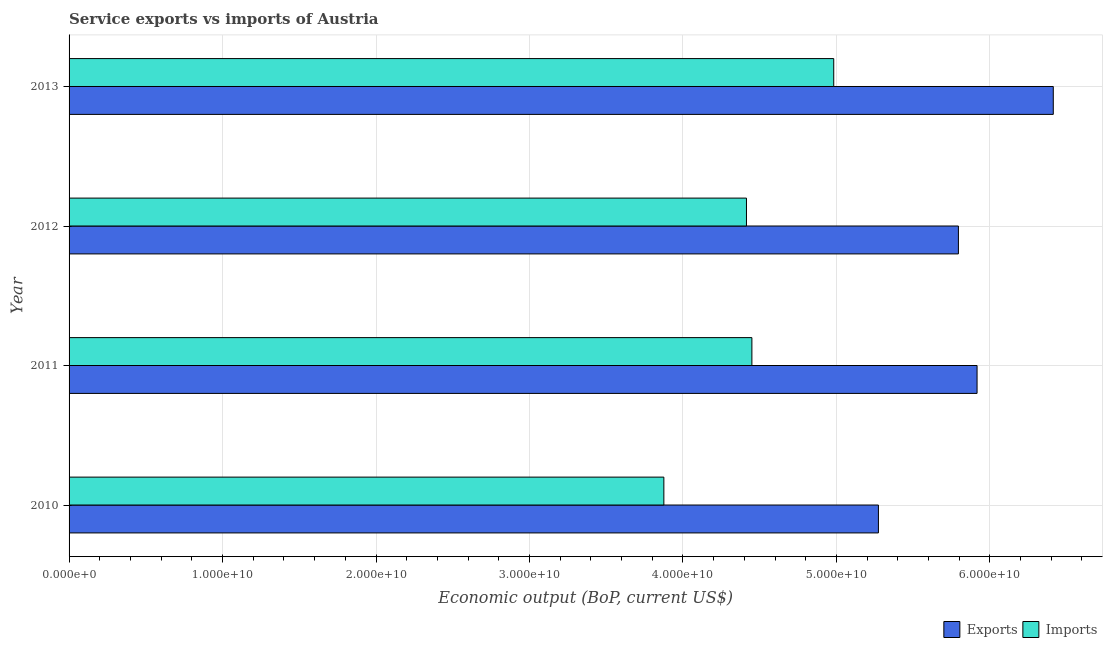How many groups of bars are there?
Ensure brevity in your answer.  4. What is the label of the 3rd group of bars from the top?
Your response must be concise. 2011. In how many cases, is the number of bars for a given year not equal to the number of legend labels?
Offer a very short reply. 0. What is the amount of service exports in 2010?
Give a very brief answer. 5.27e+1. Across all years, what is the maximum amount of service imports?
Make the answer very short. 4.98e+1. Across all years, what is the minimum amount of service imports?
Your answer should be compact. 3.88e+1. In which year was the amount of service exports maximum?
Give a very brief answer. 2013. What is the total amount of service exports in the graph?
Give a very brief answer. 2.34e+11. What is the difference between the amount of service imports in 2010 and that in 2013?
Your answer should be very brief. -1.11e+1. What is the difference between the amount of service imports in 2012 and the amount of service exports in 2013?
Offer a terse response. -2.00e+1. What is the average amount of service imports per year?
Keep it short and to the point. 4.43e+1. In the year 2010, what is the difference between the amount of service exports and amount of service imports?
Your response must be concise. 1.40e+1. What is the ratio of the amount of service exports in 2012 to that in 2013?
Your answer should be very brief. 0.9. Is the amount of service exports in 2010 less than that in 2011?
Provide a short and direct response. Yes. Is the difference between the amount of service exports in 2010 and 2013 greater than the difference between the amount of service imports in 2010 and 2013?
Provide a succinct answer. No. What is the difference between the highest and the second highest amount of service imports?
Give a very brief answer. 5.33e+09. What is the difference between the highest and the lowest amount of service exports?
Provide a succinct answer. 1.14e+1. In how many years, is the amount of service imports greater than the average amount of service imports taken over all years?
Keep it short and to the point. 2. Is the sum of the amount of service exports in 2012 and 2013 greater than the maximum amount of service imports across all years?
Ensure brevity in your answer.  Yes. What does the 1st bar from the top in 2012 represents?
Keep it short and to the point. Imports. What does the 1st bar from the bottom in 2011 represents?
Your response must be concise. Exports. What is the difference between two consecutive major ticks on the X-axis?
Give a very brief answer. 1.00e+1. Where does the legend appear in the graph?
Give a very brief answer. Bottom right. How are the legend labels stacked?
Your response must be concise. Horizontal. What is the title of the graph?
Offer a very short reply. Service exports vs imports of Austria. Does "Girls" appear as one of the legend labels in the graph?
Your response must be concise. No. What is the label or title of the X-axis?
Offer a very short reply. Economic output (BoP, current US$). What is the label or title of the Y-axis?
Provide a succinct answer. Year. What is the Economic output (BoP, current US$) in Exports in 2010?
Provide a succinct answer. 5.27e+1. What is the Economic output (BoP, current US$) of Imports in 2010?
Make the answer very short. 3.88e+1. What is the Economic output (BoP, current US$) in Exports in 2011?
Your answer should be compact. 5.92e+1. What is the Economic output (BoP, current US$) of Imports in 2011?
Offer a very short reply. 4.45e+1. What is the Economic output (BoP, current US$) in Exports in 2012?
Keep it short and to the point. 5.79e+1. What is the Economic output (BoP, current US$) of Imports in 2012?
Offer a very short reply. 4.41e+1. What is the Economic output (BoP, current US$) of Exports in 2013?
Keep it short and to the point. 6.41e+1. What is the Economic output (BoP, current US$) of Imports in 2013?
Offer a terse response. 4.98e+1. Across all years, what is the maximum Economic output (BoP, current US$) in Exports?
Provide a short and direct response. 6.41e+1. Across all years, what is the maximum Economic output (BoP, current US$) of Imports?
Provide a succinct answer. 4.98e+1. Across all years, what is the minimum Economic output (BoP, current US$) in Exports?
Keep it short and to the point. 5.27e+1. Across all years, what is the minimum Economic output (BoP, current US$) in Imports?
Your response must be concise. 3.88e+1. What is the total Economic output (BoP, current US$) of Exports in the graph?
Provide a succinct answer. 2.34e+11. What is the total Economic output (BoP, current US$) of Imports in the graph?
Your response must be concise. 1.77e+11. What is the difference between the Economic output (BoP, current US$) in Exports in 2010 and that in 2011?
Offer a terse response. -6.43e+09. What is the difference between the Economic output (BoP, current US$) in Imports in 2010 and that in 2011?
Your answer should be compact. -5.74e+09. What is the difference between the Economic output (BoP, current US$) of Exports in 2010 and that in 2012?
Provide a succinct answer. -5.21e+09. What is the difference between the Economic output (BoP, current US$) of Imports in 2010 and that in 2012?
Ensure brevity in your answer.  -5.38e+09. What is the difference between the Economic output (BoP, current US$) of Exports in 2010 and that in 2013?
Provide a short and direct response. -1.14e+1. What is the difference between the Economic output (BoP, current US$) of Imports in 2010 and that in 2013?
Offer a terse response. -1.11e+1. What is the difference between the Economic output (BoP, current US$) of Exports in 2011 and that in 2012?
Provide a succinct answer. 1.22e+09. What is the difference between the Economic output (BoP, current US$) of Imports in 2011 and that in 2012?
Provide a succinct answer. 3.54e+08. What is the difference between the Economic output (BoP, current US$) in Exports in 2011 and that in 2013?
Ensure brevity in your answer.  -4.97e+09. What is the difference between the Economic output (BoP, current US$) of Imports in 2011 and that in 2013?
Give a very brief answer. -5.33e+09. What is the difference between the Economic output (BoP, current US$) of Exports in 2012 and that in 2013?
Offer a terse response. -6.18e+09. What is the difference between the Economic output (BoP, current US$) in Imports in 2012 and that in 2013?
Offer a very short reply. -5.69e+09. What is the difference between the Economic output (BoP, current US$) in Exports in 2010 and the Economic output (BoP, current US$) in Imports in 2011?
Offer a very short reply. 8.25e+09. What is the difference between the Economic output (BoP, current US$) in Exports in 2010 and the Economic output (BoP, current US$) in Imports in 2012?
Offer a terse response. 8.60e+09. What is the difference between the Economic output (BoP, current US$) in Exports in 2010 and the Economic output (BoP, current US$) in Imports in 2013?
Ensure brevity in your answer.  2.91e+09. What is the difference between the Economic output (BoP, current US$) in Exports in 2011 and the Economic output (BoP, current US$) in Imports in 2012?
Offer a very short reply. 1.50e+1. What is the difference between the Economic output (BoP, current US$) in Exports in 2011 and the Economic output (BoP, current US$) in Imports in 2013?
Offer a terse response. 9.34e+09. What is the difference between the Economic output (BoP, current US$) in Exports in 2012 and the Economic output (BoP, current US$) in Imports in 2013?
Offer a terse response. 8.12e+09. What is the average Economic output (BoP, current US$) of Exports per year?
Give a very brief answer. 5.85e+1. What is the average Economic output (BoP, current US$) in Imports per year?
Provide a short and direct response. 4.43e+1. In the year 2010, what is the difference between the Economic output (BoP, current US$) in Exports and Economic output (BoP, current US$) in Imports?
Offer a very short reply. 1.40e+1. In the year 2011, what is the difference between the Economic output (BoP, current US$) of Exports and Economic output (BoP, current US$) of Imports?
Your response must be concise. 1.47e+1. In the year 2012, what is the difference between the Economic output (BoP, current US$) in Exports and Economic output (BoP, current US$) in Imports?
Offer a terse response. 1.38e+1. In the year 2013, what is the difference between the Economic output (BoP, current US$) in Exports and Economic output (BoP, current US$) in Imports?
Your answer should be very brief. 1.43e+1. What is the ratio of the Economic output (BoP, current US$) of Exports in 2010 to that in 2011?
Offer a very short reply. 0.89. What is the ratio of the Economic output (BoP, current US$) in Imports in 2010 to that in 2011?
Ensure brevity in your answer.  0.87. What is the ratio of the Economic output (BoP, current US$) in Exports in 2010 to that in 2012?
Ensure brevity in your answer.  0.91. What is the ratio of the Economic output (BoP, current US$) of Imports in 2010 to that in 2012?
Ensure brevity in your answer.  0.88. What is the ratio of the Economic output (BoP, current US$) in Exports in 2010 to that in 2013?
Keep it short and to the point. 0.82. What is the ratio of the Economic output (BoP, current US$) in Imports in 2010 to that in 2013?
Your answer should be compact. 0.78. What is the ratio of the Economic output (BoP, current US$) of Exports in 2011 to that in 2012?
Your answer should be compact. 1.02. What is the ratio of the Economic output (BoP, current US$) in Imports in 2011 to that in 2012?
Your answer should be very brief. 1.01. What is the ratio of the Economic output (BoP, current US$) in Exports in 2011 to that in 2013?
Ensure brevity in your answer.  0.92. What is the ratio of the Economic output (BoP, current US$) of Imports in 2011 to that in 2013?
Offer a terse response. 0.89. What is the ratio of the Economic output (BoP, current US$) of Exports in 2012 to that in 2013?
Offer a terse response. 0.9. What is the ratio of the Economic output (BoP, current US$) in Imports in 2012 to that in 2013?
Your answer should be very brief. 0.89. What is the difference between the highest and the second highest Economic output (BoP, current US$) of Exports?
Keep it short and to the point. 4.97e+09. What is the difference between the highest and the second highest Economic output (BoP, current US$) of Imports?
Your answer should be very brief. 5.33e+09. What is the difference between the highest and the lowest Economic output (BoP, current US$) of Exports?
Your answer should be compact. 1.14e+1. What is the difference between the highest and the lowest Economic output (BoP, current US$) of Imports?
Make the answer very short. 1.11e+1. 